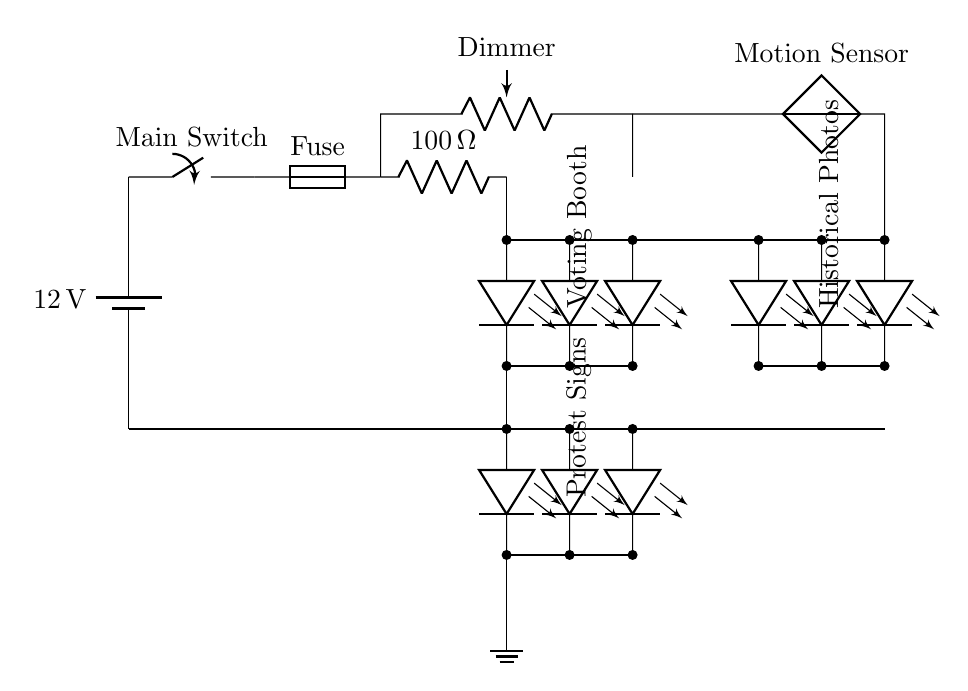What is the voltage of this circuit? The voltage is 12 volts, indicated by the battery symbol at the beginning of the circuit.
Answer: 12 volts What type of switch is used in this circuit? The circuit contains a main switch, represented by a switch symbol connected to the battery and other components.
Answer: Main switch How many LED arrays are there in total? There are three LED arrays labeled as Voting Booth, Protest Signs, and Historical Photos, which are each shown as below the main power line.
Answer: Three What is the resistance value of the current limiting resistor? The resistance is 100 ohms, which is specified next to the resistor symbol in the diagram.
Answer: 100 ohms Why is a potentiometer included in this circuit? The potentiometer functions as a dimmer, allowing for variable control of the brightness of the LED lighting, enhancing the exhibit experience.
Answer: To control brightness What is the purpose of the motion sensor in this circuit? The motion sensor is designed to detect visitor movement, enabling the LED lights to turn on or off automatically to save power and enhance engagement.
Answer: To detect movement What is the role of the fuse in the circuit? The fuse serves as a safety device to protect the circuit from excessive current, which could cause damage to other components.
Answer: To protect from excess current 